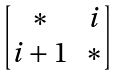Convert formula to latex. <formula><loc_0><loc_0><loc_500><loc_500>\begin{bmatrix} \ast & i \\ i + 1 & \ast \end{bmatrix}</formula> 